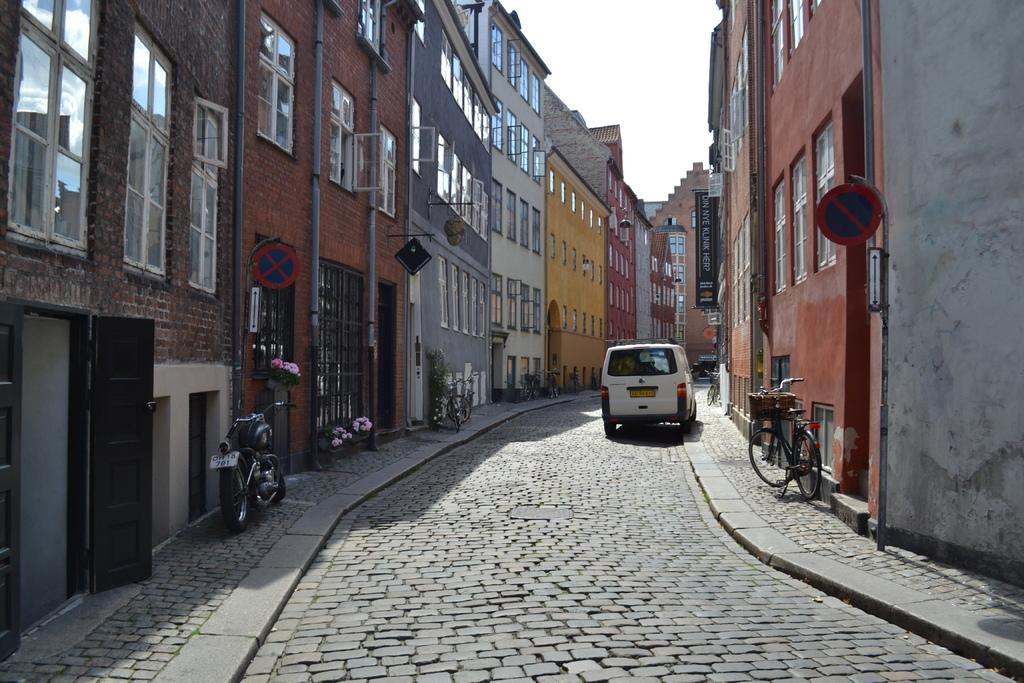What type of vehicle is present in the image? There is a motorcycle in the image. What other transportation options can be seen in the image? There are bicycles in the image. What structures are visible in the image? There are buildings in the image. What type of vegetation is present in the image? There are plants in the image. What objects are present that might be used for displaying information or advertisements? There are boards in the image. What is visible in the background of the image? The sky is visible in the background of the image. Can you tell me how many crows are sitting on the motorcycle in the image? There are no crows present in the image; it only features a motorcycle, bicycles, buildings, plants, boards, and the sky. What type of seat is available for the motorcycle in the image? The image does not show a seat for the motorcycle, as it only displays the motorcycle itself. 